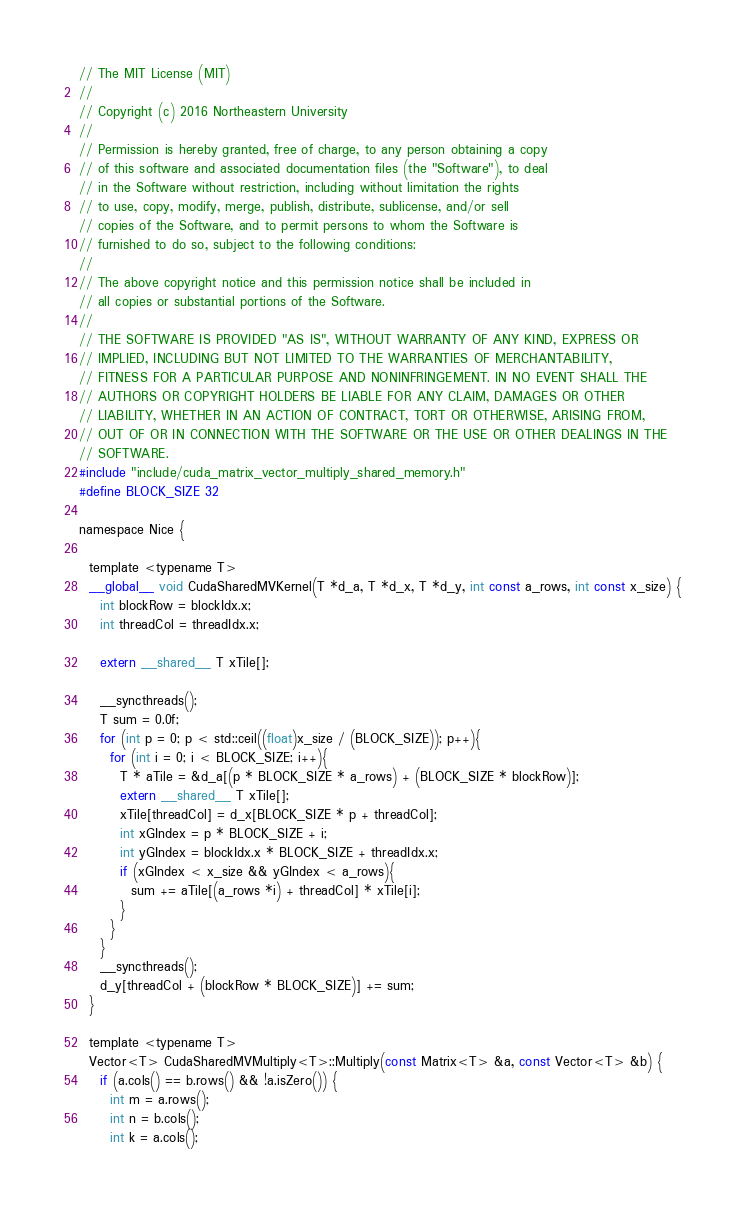<code> <loc_0><loc_0><loc_500><loc_500><_Cuda_>// The MIT License (MIT)
//
// Copyright (c) 2016 Northeastern University
//
// Permission is hereby granted, free of charge, to any person obtaining a copy
// of this software and associated documentation files (the "Software"), to deal
// in the Software without restriction, including without limitation the rights
// to use, copy, modify, merge, publish, distribute, sublicense, and/or sell
// copies of the Software, and to permit persons to whom the Software is
// furnished to do so, subject to the following conditions:
//
// The above copyright notice and this permission notice shall be included in
// all copies or substantial portions of the Software.
//
// THE SOFTWARE IS PROVIDED "AS IS", WITHOUT WARRANTY OF ANY KIND, EXPRESS OR
// IMPLIED, INCLUDING BUT NOT LIMITED TO THE WARRANTIES OF MERCHANTABILITY,
// FITNESS FOR A PARTICULAR PURPOSE AND NONINFRINGEMENT. IN NO EVENT SHALL THE
// AUTHORS OR COPYRIGHT HOLDERS BE LIABLE FOR ANY CLAIM, DAMAGES OR OTHER
// LIABILITY, WHETHER IN AN ACTION OF CONTRACT, TORT OR OTHERWISE, ARISING FROM,
// OUT OF OR IN CONNECTION WITH THE SOFTWARE OR THE USE OR OTHER DEALINGS IN THE
// SOFTWARE.
#include "include/cuda_matrix_vector_multiply_shared_memory.h"
#define BLOCK_SIZE 32

namespace Nice {

  template <typename T>
  __global__ void CudaSharedMVKernel(T *d_a, T *d_x, T *d_y, int const a_rows, int const x_size) {
    int blockRow = blockIdx.x;
    int threadCol = threadIdx.x;

    extern __shared__ T xTile[];

    __syncthreads();
    T sum = 0.0f;
    for (int p = 0; p < std::ceil((float)x_size / (BLOCK_SIZE)); p++){
      for (int i = 0; i < BLOCK_SIZE; i++){
        T * aTile = &d_a[(p * BLOCK_SIZE * a_rows) + (BLOCK_SIZE * blockRow)];
        extern __shared__ T xTile[];
        xTile[threadCol] = d_x[BLOCK_SIZE * p + threadCol];
        int xGIndex = p * BLOCK_SIZE + i;
        int yGIndex = blockIdx.x * BLOCK_SIZE + threadIdx.x;
        if (xGIndex < x_size && yGIndex < a_rows){
          sum += aTile[(a_rows *i) + threadCol] * xTile[i];
        }
      }
    }
    __syncthreads();
    d_y[threadCol + (blockRow * BLOCK_SIZE)] += sum;
  }

  template <typename T>
  Vector<T> CudaSharedMVMultiply<T>::Multiply(const Matrix<T> &a, const Vector<T> &b) {
    if (a.cols() == b.rows() && !a.isZero()) {
      int m = a.rows();
      int n = b.cols();
      int k = a.cols();
</code> 